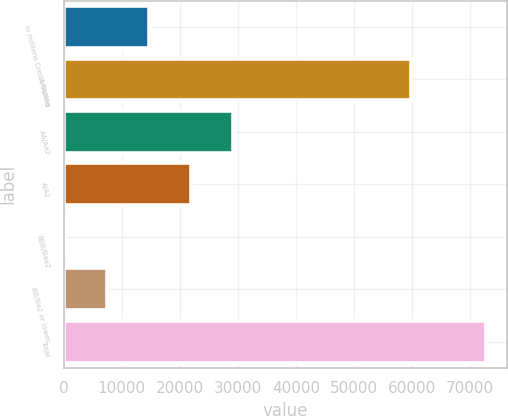<chart> <loc_0><loc_0><loc_500><loc_500><bar_chart><fcel>in millions Credit Rating<fcel>AAA/Aaa<fcel>AA/Aa2<fcel>A/A2<fcel>BBB/Baa2<fcel>BB/Ba2 or lower<fcel>Total<nl><fcel>14794.6<fcel>59825<fcel>29263.2<fcel>22028.9<fcel>326<fcel>7560.3<fcel>72669<nl></chart> 